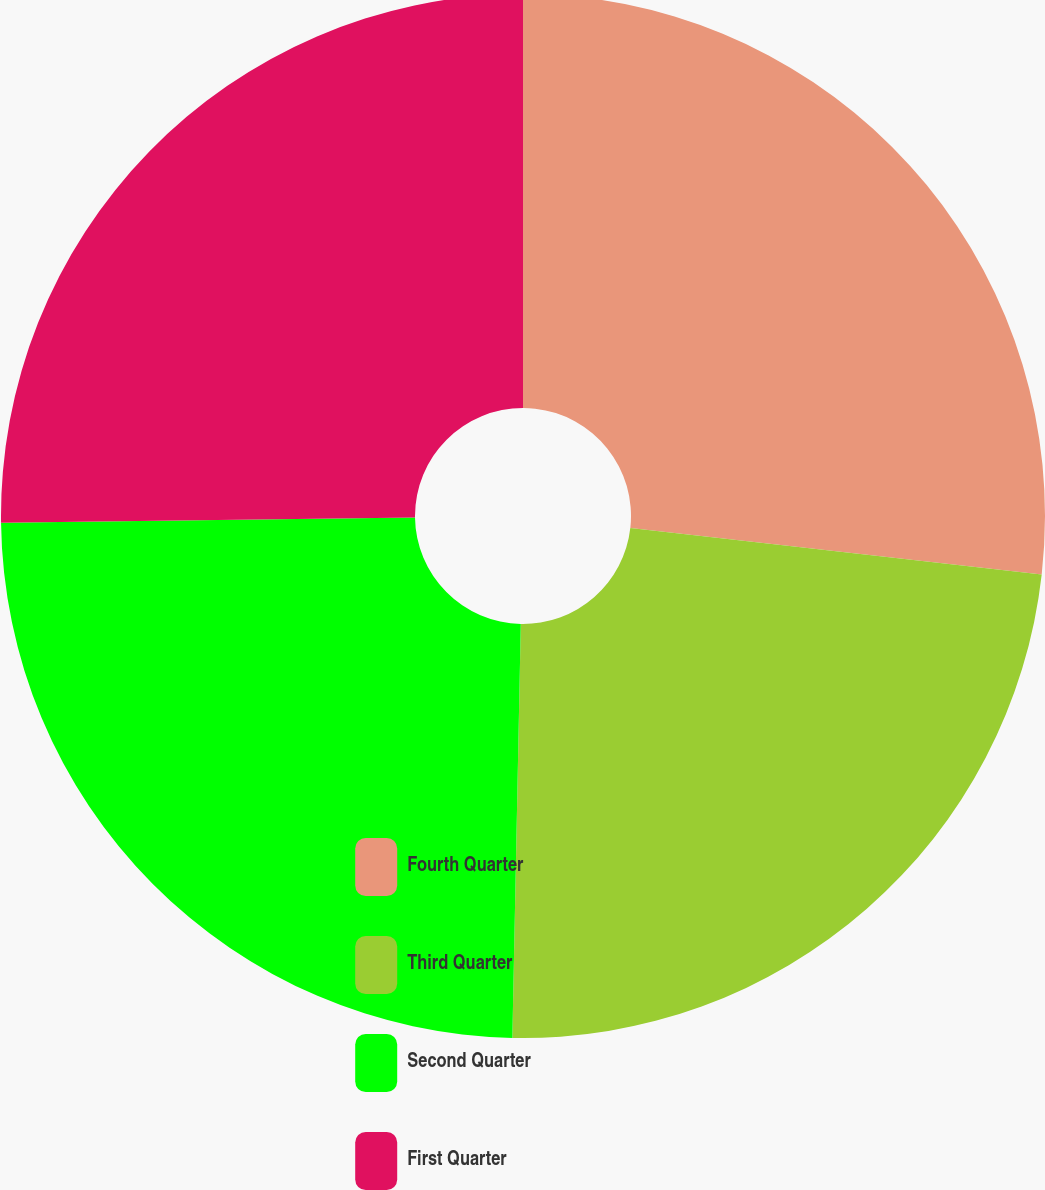Convert chart. <chart><loc_0><loc_0><loc_500><loc_500><pie_chart><fcel>Fourth Quarter<fcel>Third Quarter<fcel>Second Quarter<fcel>First Quarter<nl><fcel>26.79%<fcel>23.54%<fcel>24.47%<fcel>25.21%<nl></chart> 